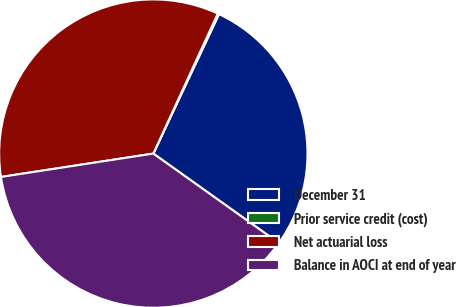<chart> <loc_0><loc_0><loc_500><loc_500><pie_chart><fcel>December 31<fcel>Prior service credit (cost)<fcel>Net actuarial loss<fcel>Balance in AOCI at end of year<nl><fcel>27.85%<fcel>0.14%<fcel>34.29%<fcel>37.72%<nl></chart> 